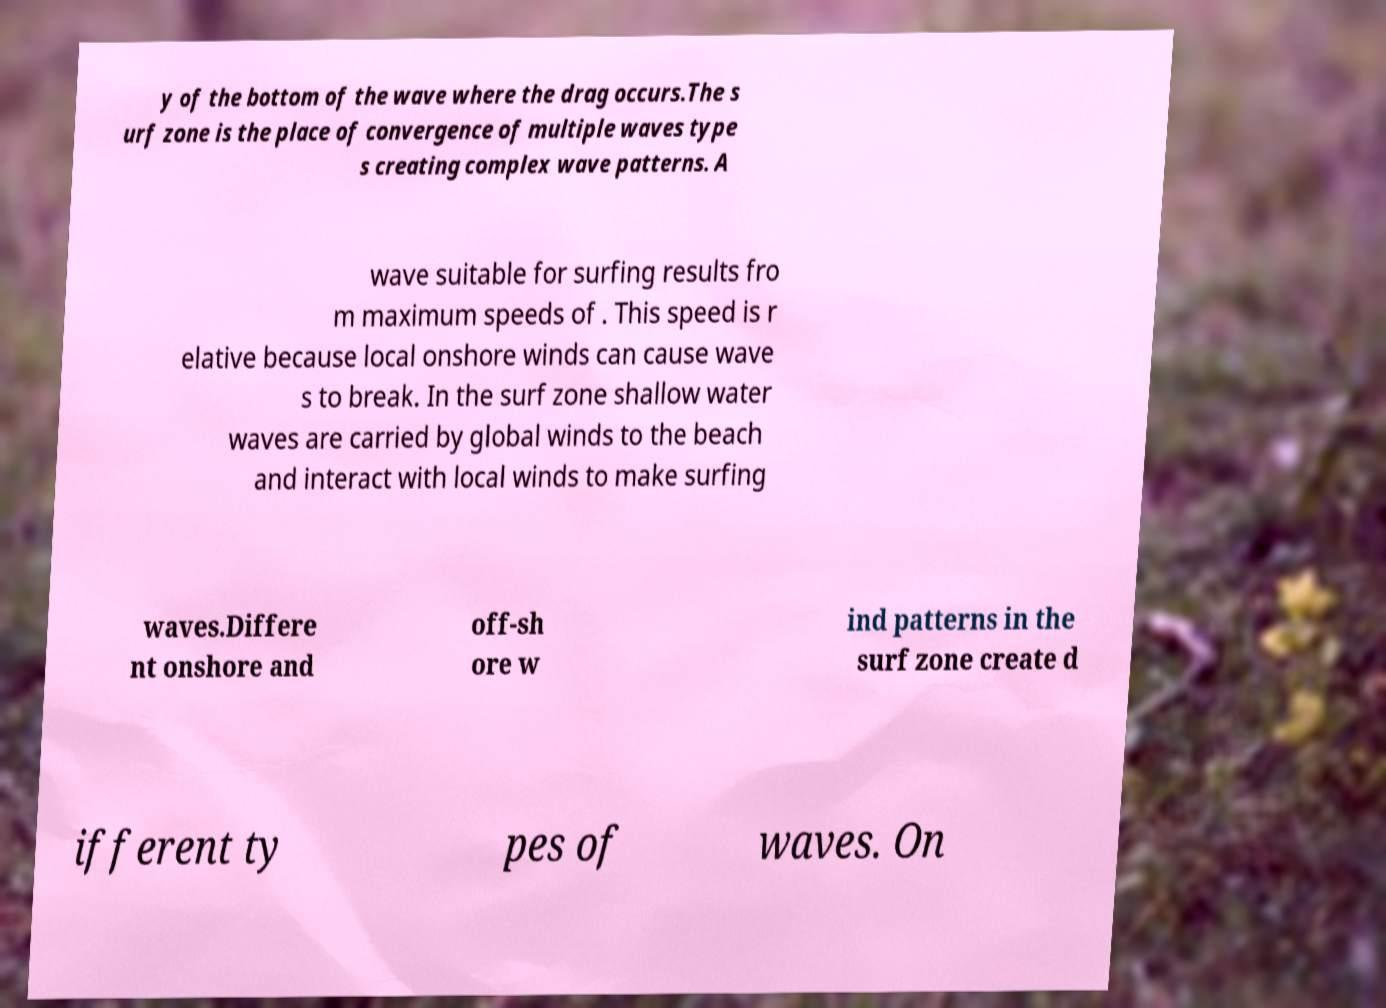Please identify and transcribe the text found in this image. y of the bottom of the wave where the drag occurs.The s urf zone is the place of convergence of multiple waves type s creating complex wave patterns. A wave suitable for surfing results fro m maximum speeds of . This speed is r elative because local onshore winds can cause wave s to break. In the surf zone shallow water waves are carried by global winds to the beach and interact with local winds to make surfing waves.Differe nt onshore and off-sh ore w ind patterns in the surf zone create d ifferent ty pes of waves. On 